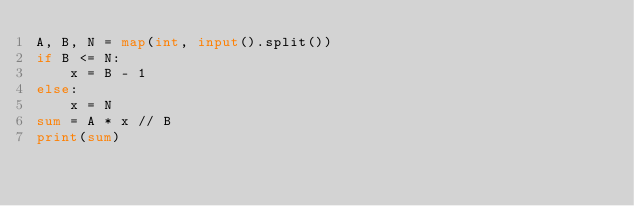Convert code to text. <code><loc_0><loc_0><loc_500><loc_500><_Python_>A, B, N = map(int, input().split())
if B <= N:
    x = B - 1
else:
    x = N
sum = A * x // B 
print(sum)</code> 